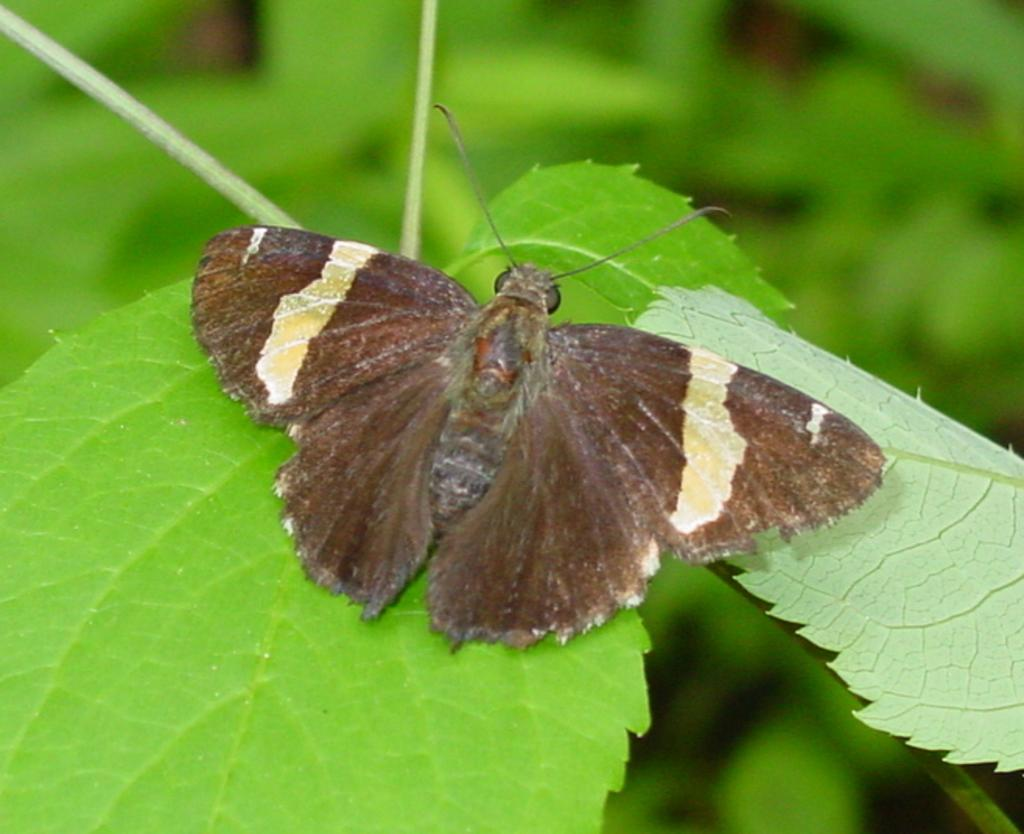What is the main subject of the image? There is a butterfly in the image. Where is the butterfly located in the image? The butterfly is sitting on leaves. What else can be seen in the image besides the butterfly? There are leaves in the image. What is visible in the background of the image? There is greenery in the background of the image. Can you tell me how many tigers are visible in the image? There are no tigers present in the image; it features a butterfly sitting on leaves. What type of star can be seen in the image? There is no star visible in the image; it is a close-up of a butterfly sitting on leaves surrounded by greenery. 